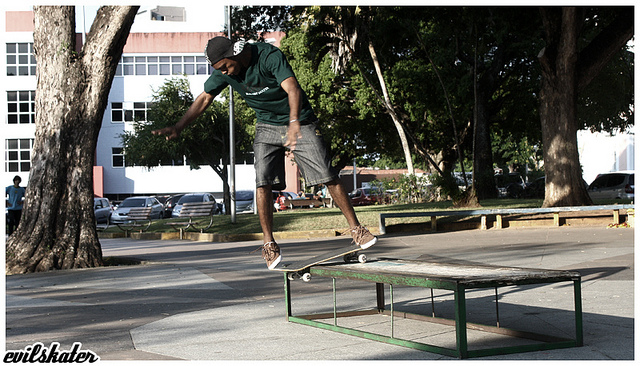Please identify all text content in this image. evilshater 